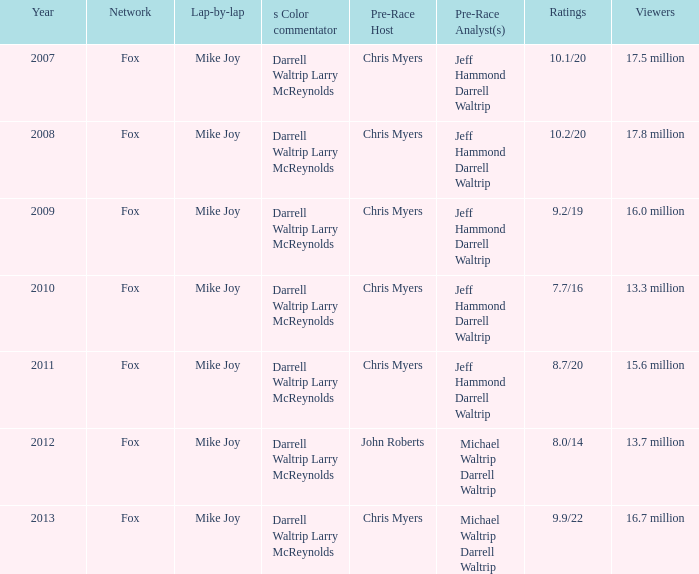What was the total number of ratings in the year 2013? 9.9/22. 